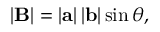<formula> <loc_0><loc_0><loc_500><loc_500>\left | B \right | = \left | a \right | \left | b \right | \sin { \theta } ,</formula> 